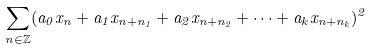<formula> <loc_0><loc_0><loc_500><loc_500>\sum _ { n \in \mathbb { Z } } ( a _ { 0 } x _ { n } + a _ { 1 } x _ { n + n _ { 1 } } + a _ { 2 } x _ { n + n _ { 2 } } + \cdots + a _ { k } x _ { n + n _ { k } } ) ^ { 2 }</formula> 